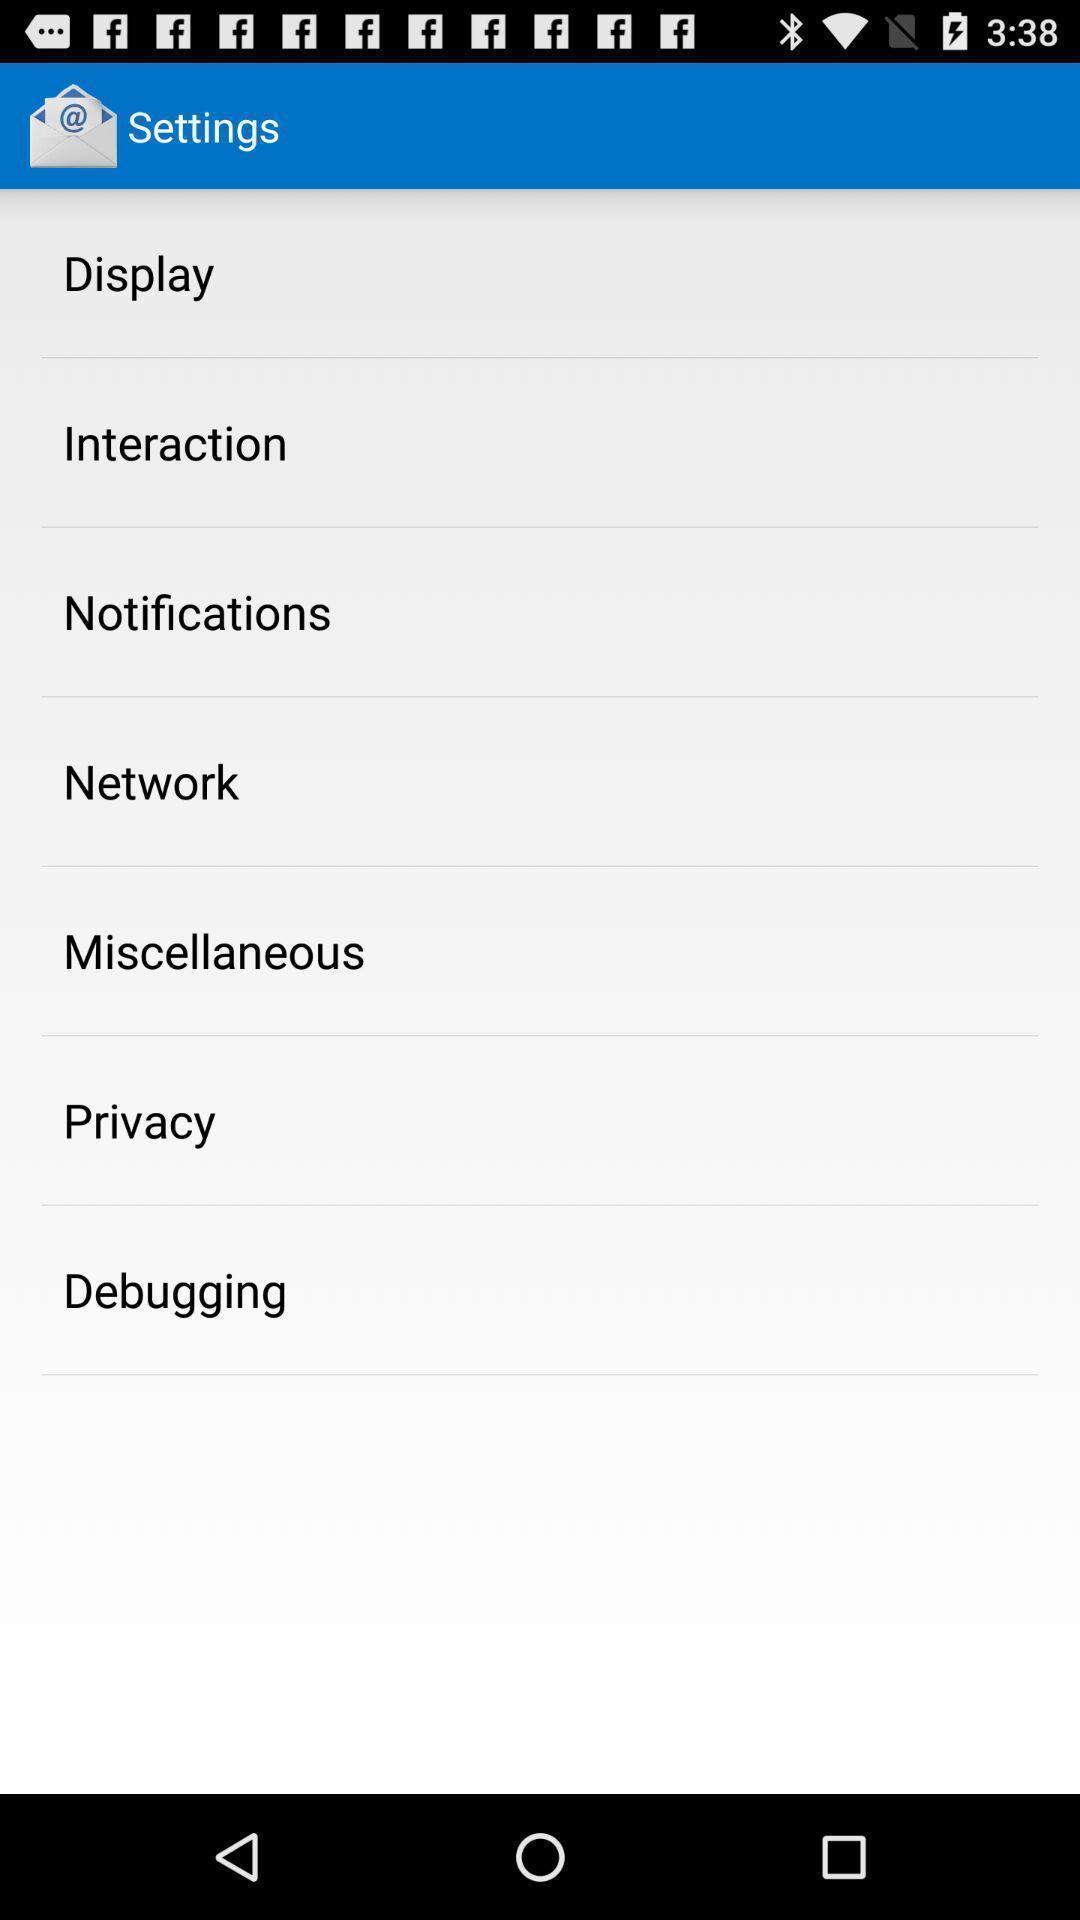Summarize the main components in this picture. Settings page. 